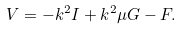Convert formula to latex. <formula><loc_0><loc_0><loc_500><loc_500>V = - k ^ { 2 } I + k ^ { 2 } \mu G - F .</formula> 